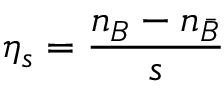<formula> <loc_0><loc_0><loc_500><loc_500>\eta _ { s } = { \frac { n _ { B } - n _ { \bar { B } } } { s } }</formula> 